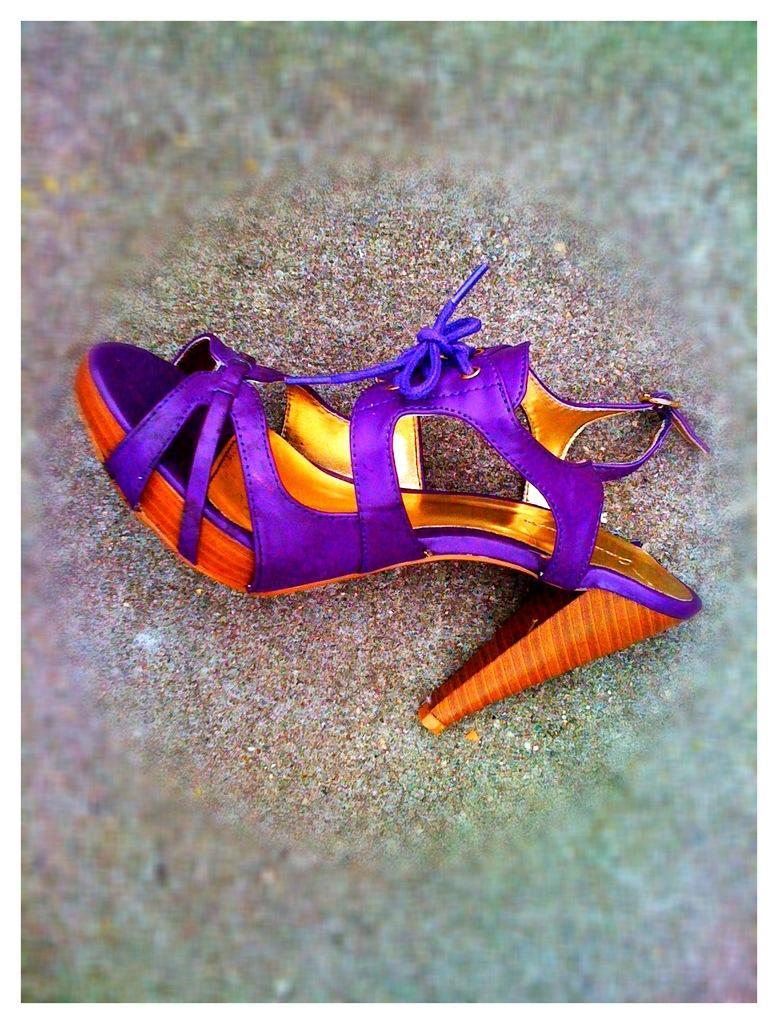Please provide a concise description of this image. In this image there is a heel on the ground. There are laces and a buckle to the heel. The edges of the image are blurry. 